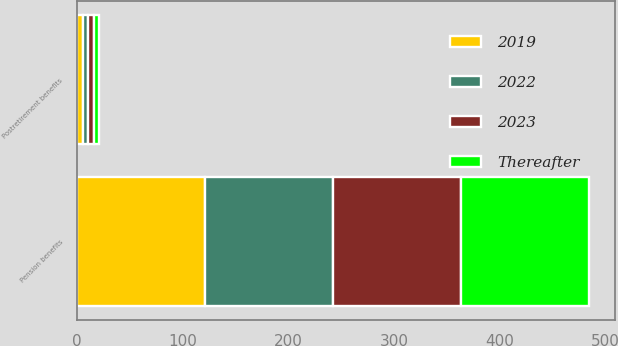Convert chart to OTSL. <chart><loc_0><loc_0><loc_500><loc_500><stacked_bar_chart><ecel><fcel>Pension benefits<fcel>Postretirement benefits<nl><fcel>2019<fcel>121.2<fcel>5.3<nl><fcel>Thereafter<fcel>121.4<fcel>5.3<nl><fcel>2022<fcel>121.3<fcel>5.2<nl><fcel>2023<fcel>120.8<fcel>5.1<nl></chart> 